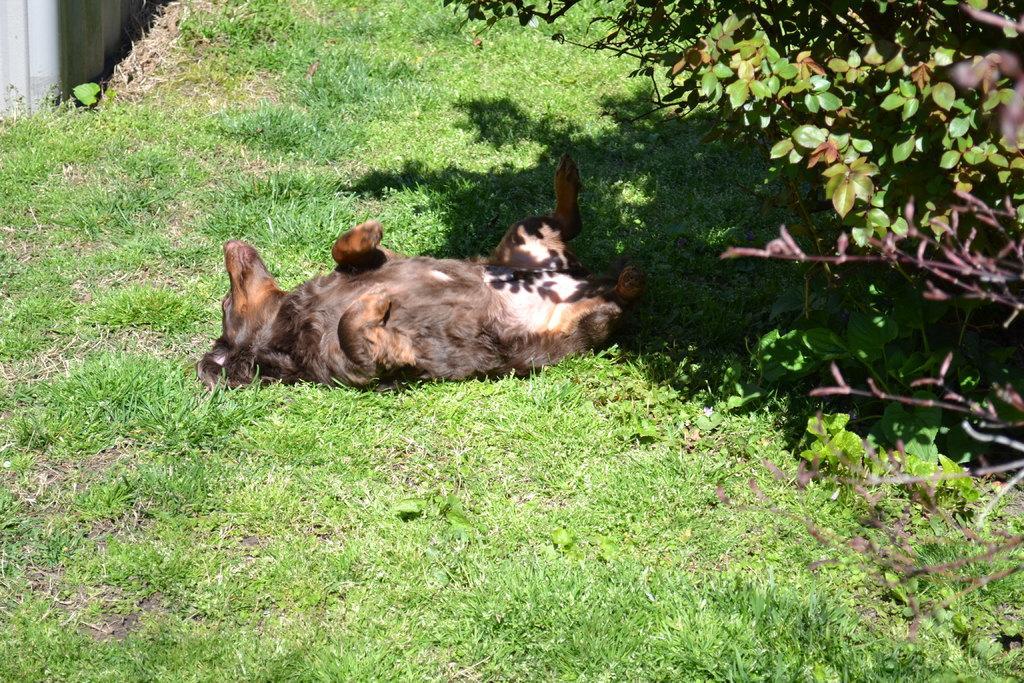Could you give a brief overview of what you see in this image? In this image we can see an animal on the ground and there are trees on the right side and a wall on the left side. 